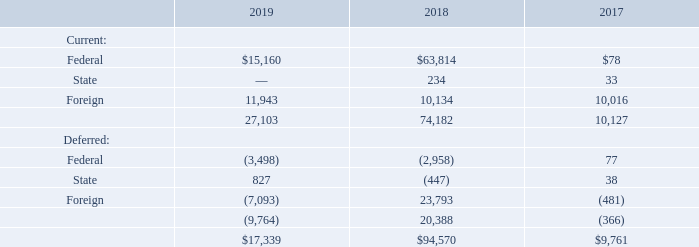6. Income Taxes
Income tax expense (benefit) for fiscal 2019, 2018 and 2017 were as follows (in thousands):
Which years does the table provide information for the Income tax expense (benefit)? 2019, 2018, 2017. What was the current federal income tax expense  in 2017?
Answer scale should be: thousand. 78. What was the deferred federal income tax expense  in 2018?
Answer scale should be: thousand. (2,958). How many years did the total income tax expense exceed $50,000 thousand? 2018
Answer: 1. What was the change in the total current income tax expense between 2017 and 2018?
Answer scale should be: thousand. 74,182-10,127
Answer: 64055. What was the percentage change in the deferred State income tax expense between 2017 and 2019?
Answer scale should be: percent. (827-38)/38
Answer: 2076.32. 